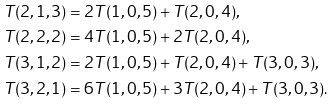Convert formula to latex. <formula><loc_0><loc_0><loc_500><loc_500>T ( 2 , 1 , 3 ) & = 2 T ( 1 , 0 , 5 ) + T ( 2 , 0 , 4 ) , \\ T ( 2 , 2 , 2 ) & = 4 T ( 1 , 0 , 5 ) + 2 T ( 2 , 0 , 4 ) , \\ T ( 3 , 1 , 2 ) & = 2 T ( 1 , 0 , 5 ) + T ( 2 , 0 , 4 ) + T ( 3 , 0 , 3 ) , \\ T ( 3 , 2 , 1 ) & = 6 T ( 1 , 0 , 5 ) + 3 T ( 2 , 0 , 4 ) + T ( 3 , 0 , 3 ) .</formula> 